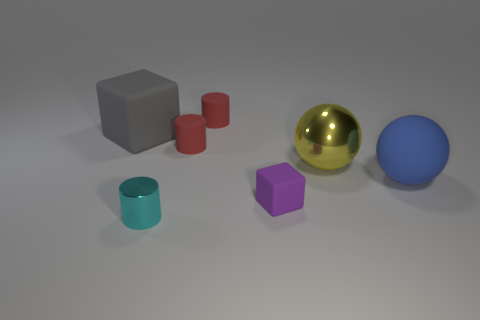Subtract 1 cylinders. How many cylinders are left? 2 Add 2 large cyan rubber cylinders. How many objects exist? 9 Subtract all spheres. How many objects are left? 5 Subtract all tiny green shiny balls. Subtract all small cyan metal objects. How many objects are left? 6 Add 5 tiny rubber cylinders. How many tiny rubber cylinders are left? 7 Add 4 big spheres. How many big spheres exist? 6 Subtract 1 yellow balls. How many objects are left? 6 